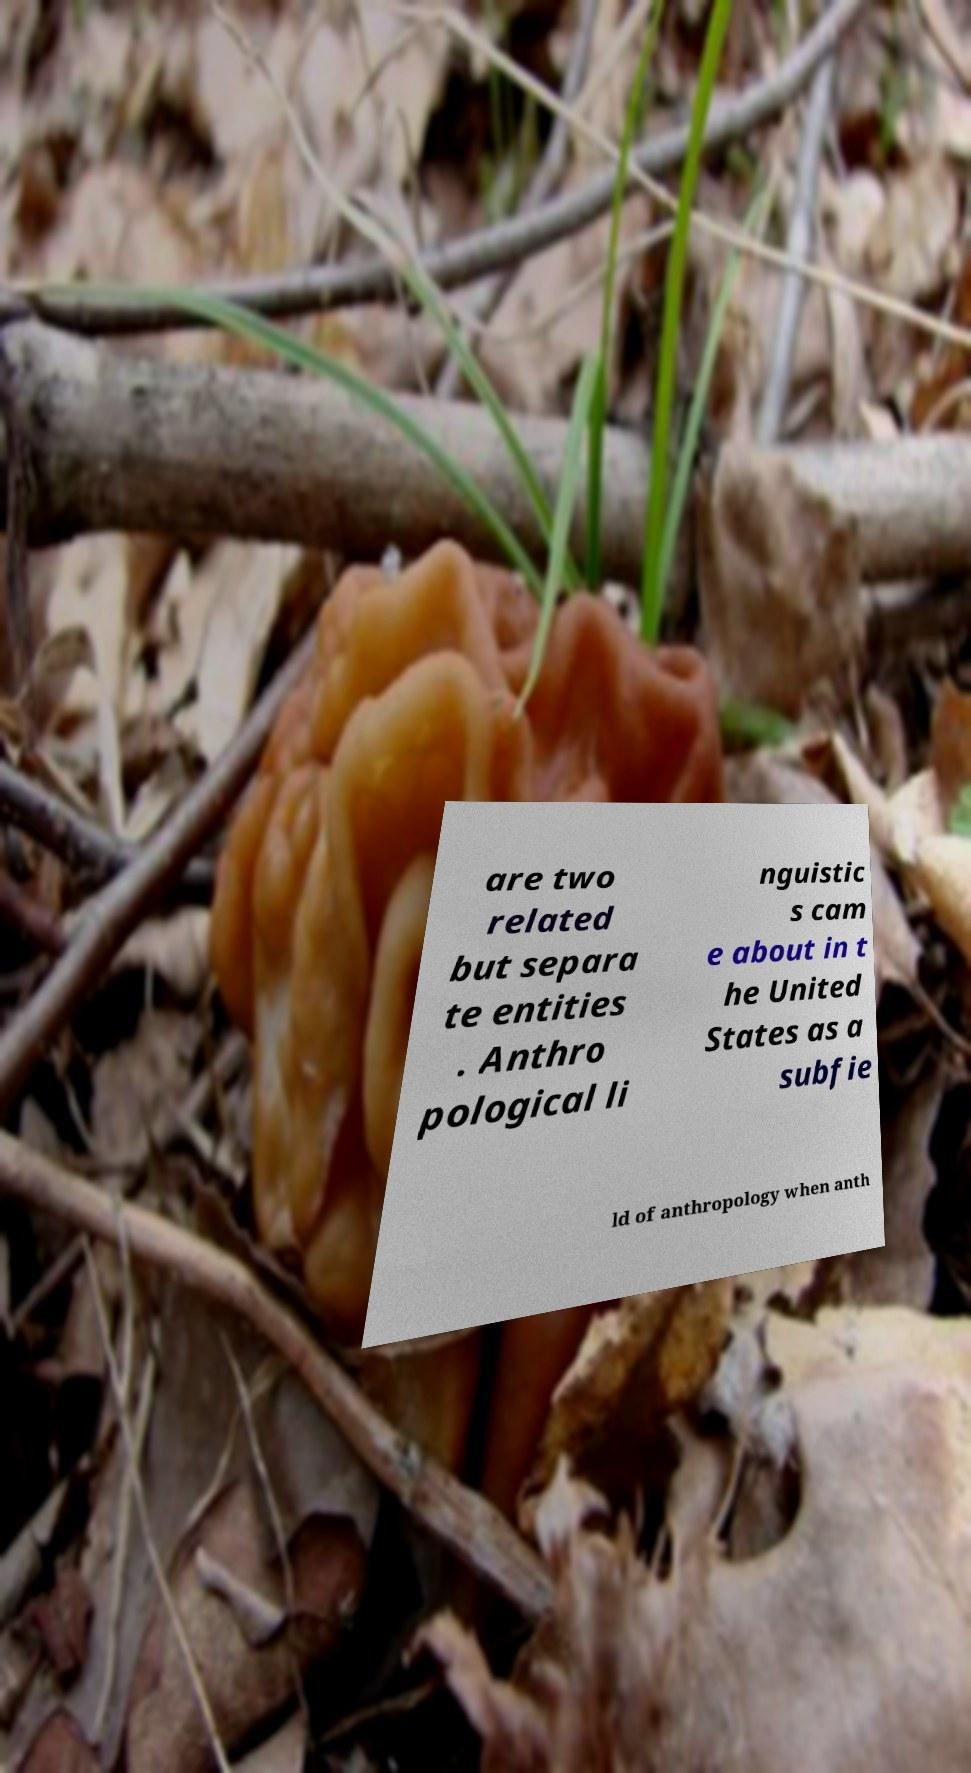Please read and relay the text visible in this image. What does it say? are two related but separa te entities . Anthro pological li nguistic s cam e about in t he United States as a subfie ld of anthropology when anth 